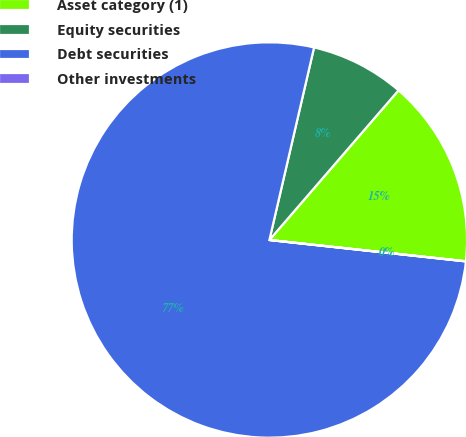<chart> <loc_0><loc_0><loc_500><loc_500><pie_chart><fcel>Asset category (1)<fcel>Equity securities<fcel>Debt securities<fcel>Other investments<nl><fcel>15.39%<fcel>7.7%<fcel>76.91%<fcel>0.01%<nl></chart> 